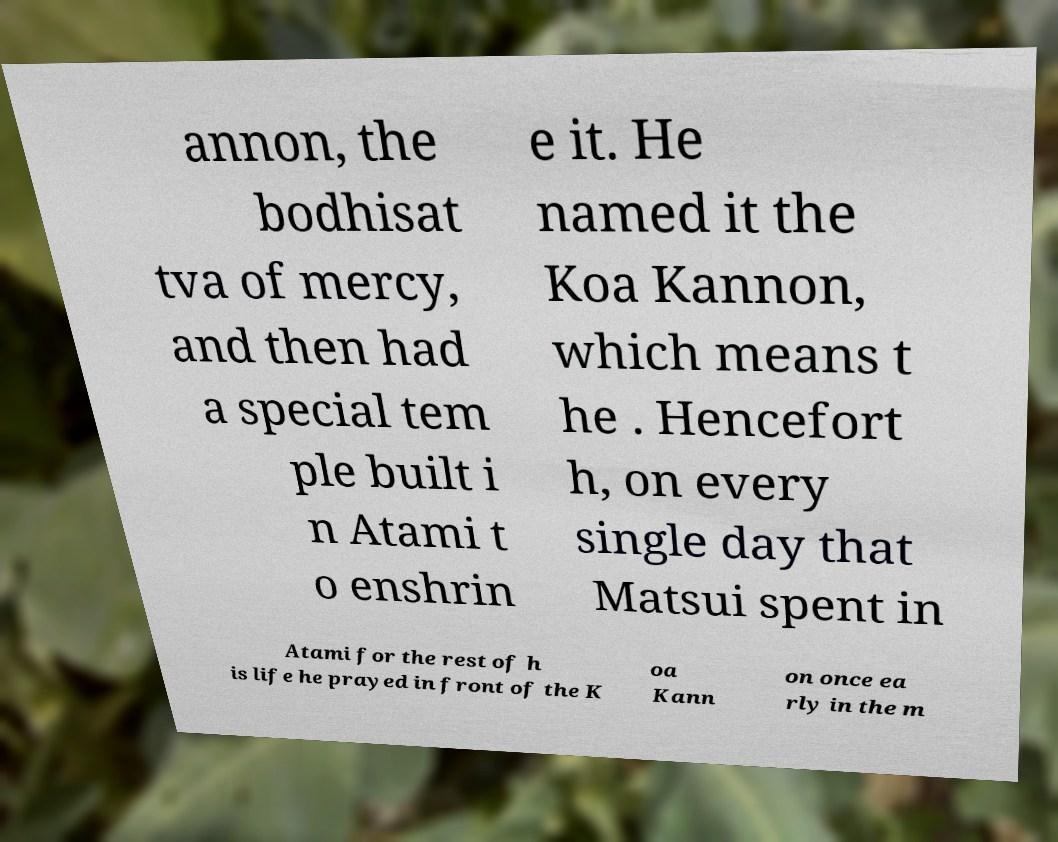Could you assist in decoding the text presented in this image and type it out clearly? annon, the bodhisat tva of mercy, and then had a special tem ple built i n Atami t o enshrin e it. He named it the Koa Kannon, which means t he . Hencefort h, on every single day that Matsui spent in Atami for the rest of h is life he prayed in front of the K oa Kann on once ea rly in the m 